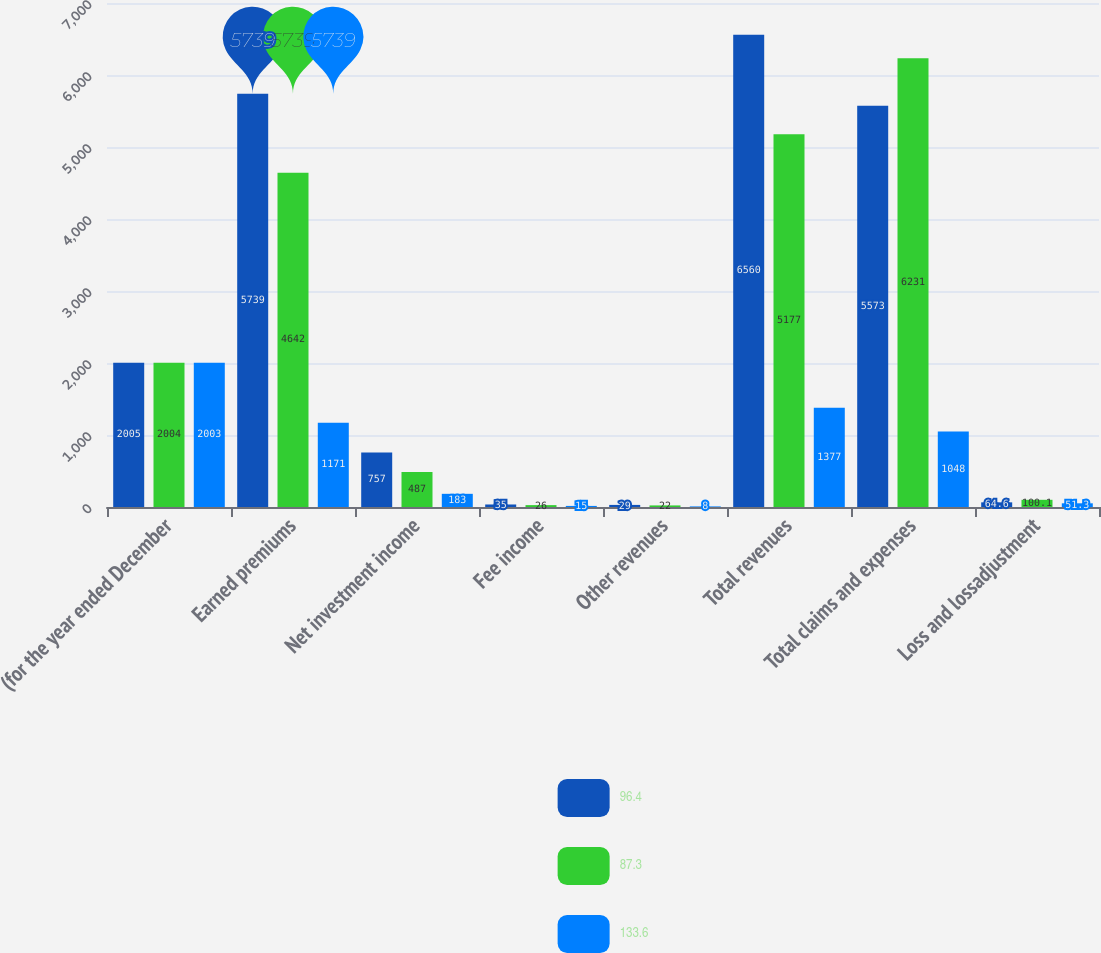<chart> <loc_0><loc_0><loc_500><loc_500><stacked_bar_chart><ecel><fcel>(for the year ended December<fcel>Earned premiums<fcel>Net investment income<fcel>Fee income<fcel>Other revenues<fcel>Total revenues<fcel>Total claims and expenses<fcel>Loss and lossadjustment<nl><fcel>96.4<fcel>2005<fcel>5739<fcel>757<fcel>35<fcel>29<fcel>6560<fcel>5573<fcel>64.6<nl><fcel>87.3<fcel>2004<fcel>4642<fcel>487<fcel>26<fcel>22<fcel>5177<fcel>6231<fcel>100.1<nl><fcel>133.6<fcel>2003<fcel>1171<fcel>183<fcel>15<fcel>8<fcel>1377<fcel>1048<fcel>51.3<nl></chart> 